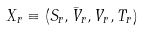<formula> <loc_0><loc_0><loc_500><loc_500>X _ { r } \equiv ( S _ { r } , \bar { V } _ { r } , V _ { r } , T _ { r } )</formula> 